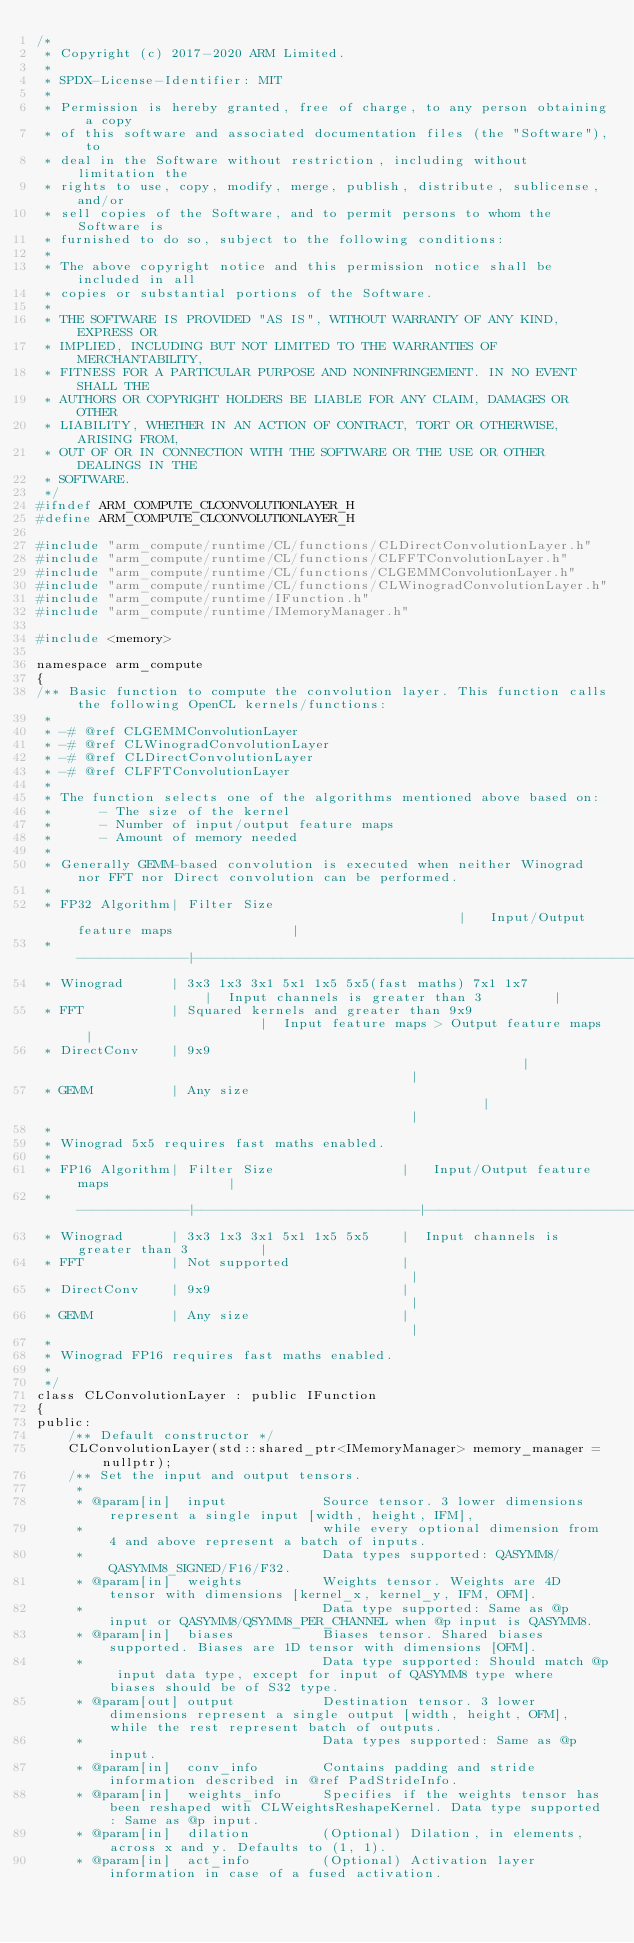<code> <loc_0><loc_0><loc_500><loc_500><_C_>/*
 * Copyright (c) 2017-2020 ARM Limited.
 *
 * SPDX-License-Identifier: MIT
 *
 * Permission is hereby granted, free of charge, to any person obtaining a copy
 * of this software and associated documentation files (the "Software"), to
 * deal in the Software without restriction, including without limitation the
 * rights to use, copy, modify, merge, publish, distribute, sublicense, and/or
 * sell copies of the Software, and to permit persons to whom the Software is
 * furnished to do so, subject to the following conditions:
 *
 * The above copyright notice and this permission notice shall be included in all
 * copies or substantial portions of the Software.
 *
 * THE SOFTWARE IS PROVIDED "AS IS", WITHOUT WARRANTY OF ANY KIND, EXPRESS OR
 * IMPLIED, INCLUDING BUT NOT LIMITED TO THE WARRANTIES OF MERCHANTABILITY,
 * FITNESS FOR A PARTICULAR PURPOSE AND NONINFRINGEMENT. IN NO EVENT SHALL THE
 * AUTHORS OR COPYRIGHT HOLDERS BE LIABLE FOR ANY CLAIM, DAMAGES OR OTHER
 * LIABILITY, WHETHER IN AN ACTION OF CONTRACT, TORT OR OTHERWISE, ARISING FROM,
 * OUT OF OR IN CONNECTION WITH THE SOFTWARE OR THE USE OR OTHER DEALINGS IN THE
 * SOFTWARE.
 */
#ifndef ARM_COMPUTE_CLCONVOLUTIONLAYER_H
#define ARM_COMPUTE_CLCONVOLUTIONLAYER_H

#include "arm_compute/runtime/CL/functions/CLDirectConvolutionLayer.h"
#include "arm_compute/runtime/CL/functions/CLFFTConvolutionLayer.h"
#include "arm_compute/runtime/CL/functions/CLGEMMConvolutionLayer.h"
#include "arm_compute/runtime/CL/functions/CLWinogradConvolutionLayer.h"
#include "arm_compute/runtime/IFunction.h"
#include "arm_compute/runtime/IMemoryManager.h"

#include <memory>

namespace arm_compute
{
/** Basic function to compute the convolution layer. This function calls the following OpenCL kernels/functions:
 *
 * -# @ref CLGEMMConvolutionLayer
 * -# @ref CLWinogradConvolutionLayer
 * -# @ref CLDirectConvolutionLayer
 * -# @ref CLFFTConvolutionLayer
 *
 * The function selects one of the algorithms mentioned above based on:
 *      - The size of the kernel
 *      - Number of input/output feature maps
 *      - Amount of memory needed
 *
 * Generally GEMM-based convolution is executed when neither Winograd nor FFT nor Direct convolution can be performed.
 *
 * FP32 Algorithm| Filter Size                                                 |   Input/Output feature maps               |
 * --------------|-------------------------------------------------------------|-------------------------------------------|
 * Winograd      | 3x3 1x3 3x1 5x1 1x5 5x5(fast maths) 7x1 1x7                 |  Input channels is greater than 3         |
 * FFT           | Squared kernels and greater than 9x9                        |  Input feature maps > Output feature maps |
 * DirectConv    | 9x9                                                         |                                           |
 * GEMM          | Any size                                                    |                                           |
 *
 * Winograd 5x5 requires fast maths enabled.
 *
 * FP16 Algorithm| Filter Size                |   Input/Output feature maps               |
 * --------------|----------------------------|-------------------------------------------|
 * Winograd      | 3x3 1x3 3x1 5x1 1x5 5x5    |  Input channels is greater than 3         |
 * FFT           | Not supported              |                                           |
 * DirectConv    | 9x9                        |                                           |
 * GEMM          | Any size                   |                                           |
 *
 * Winograd FP16 requires fast maths enabled.
 *
 */
class CLConvolutionLayer : public IFunction
{
public:
    /** Default constructor */
    CLConvolutionLayer(std::shared_ptr<IMemoryManager> memory_manager = nullptr);
    /** Set the input and output tensors.
     *
     * @param[in]  input            Source tensor. 3 lower dimensions represent a single input [width, height, IFM],
     *                              while every optional dimension from 4 and above represent a batch of inputs.
     *                              Data types supported: QASYMM8/QASYMM8_SIGNED/F16/F32.
     * @param[in]  weights          Weights tensor. Weights are 4D tensor with dimensions [kernel_x, kernel_y, IFM, OFM].
     *                              Data type supported: Same as @p input or QASYMM8/QSYMM8_PER_CHANNEL when @p input is QASYMM8.
     * @param[in]  biases           Biases tensor. Shared biases supported. Biases are 1D tensor with dimensions [OFM].
     *                              Data type supported: Should match @p input data type, except for input of QASYMM8 type where biases should be of S32 type.
     * @param[out] output           Destination tensor. 3 lower dimensions represent a single output [width, height, OFM], while the rest represent batch of outputs.
     *                              Data types supported: Same as @p input.
     * @param[in]  conv_info        Contains padding and stride information described in @ref PadStrideInfo.
     * @param[in]  weights_info     Specifies if the weights tensor has been reshaped with CLWeightsReshapeKernel. Data type supported: Same as @p input.
     * @param[in]  dilation         (Optional) Dilation, in elements, across x and y. Defaults to (1, 1).
     * @param[in]  act_info         (Optional) Activation layer information in case of a fused activation.</code> 